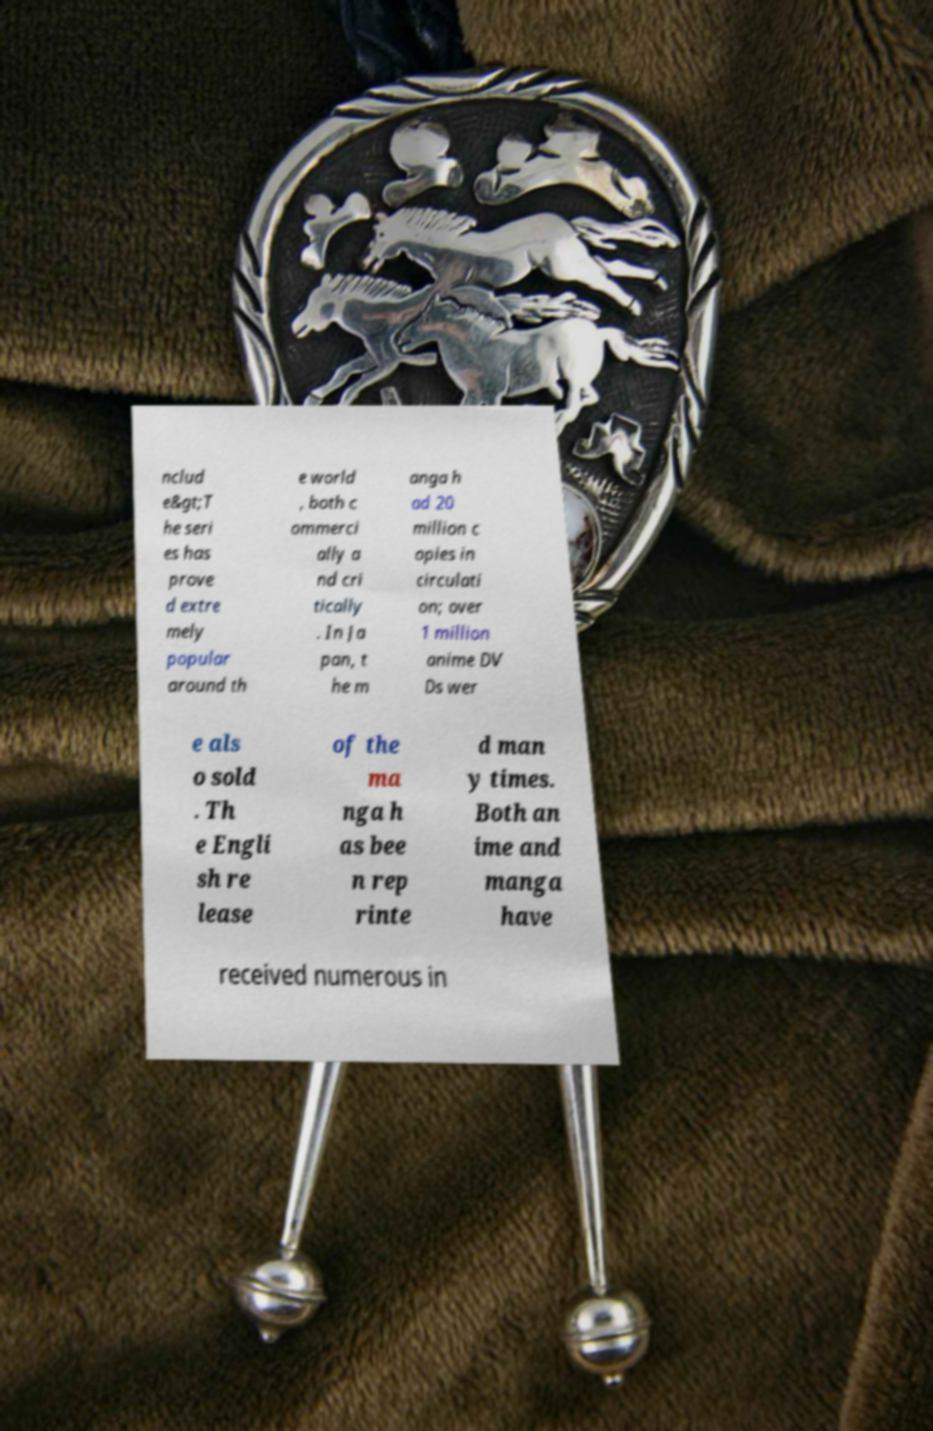What messages or text are displayed in this image? I need them in a readable, typed format. nclud e&gt;T he seri es has prove d extre mely popular around th e world , both c ommerci ally a nd cri tically . In Ja pan, t he m anga h ad 20 million c opies in circulati on; over 1 million anime DV Ds wer e als o sold . Th e Engli sh re lease of the ma nga h as bee n rep rinte d man y times. Both an ime and manga have received numerous in 